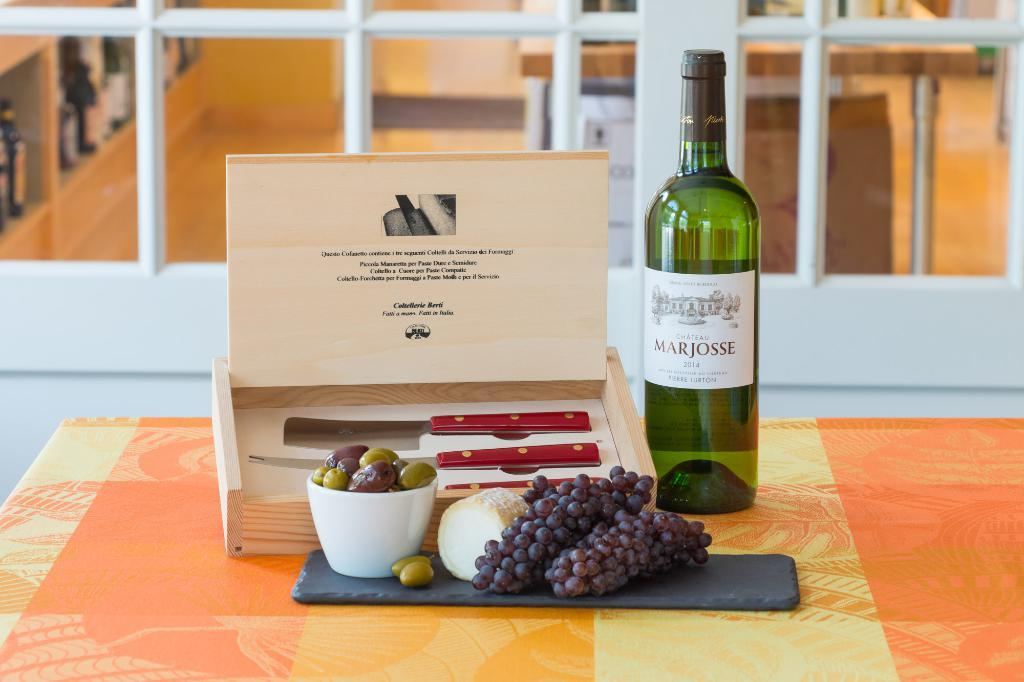What type of food is visible in the image? There are grapes and fruits in a bowl in the image. What objects are present for cutting or slicing the fruits? There are two knives in the image. What material is used to create a temporary surface in the image? There is a cart board in the image. What is placed on a table in the image? There is a bottle on a table in the image. What type of door can be seen in the background of the image? There is a railing door visible in the background of the image. What activity is the goose performing in the image? There is no goose present in the image. 